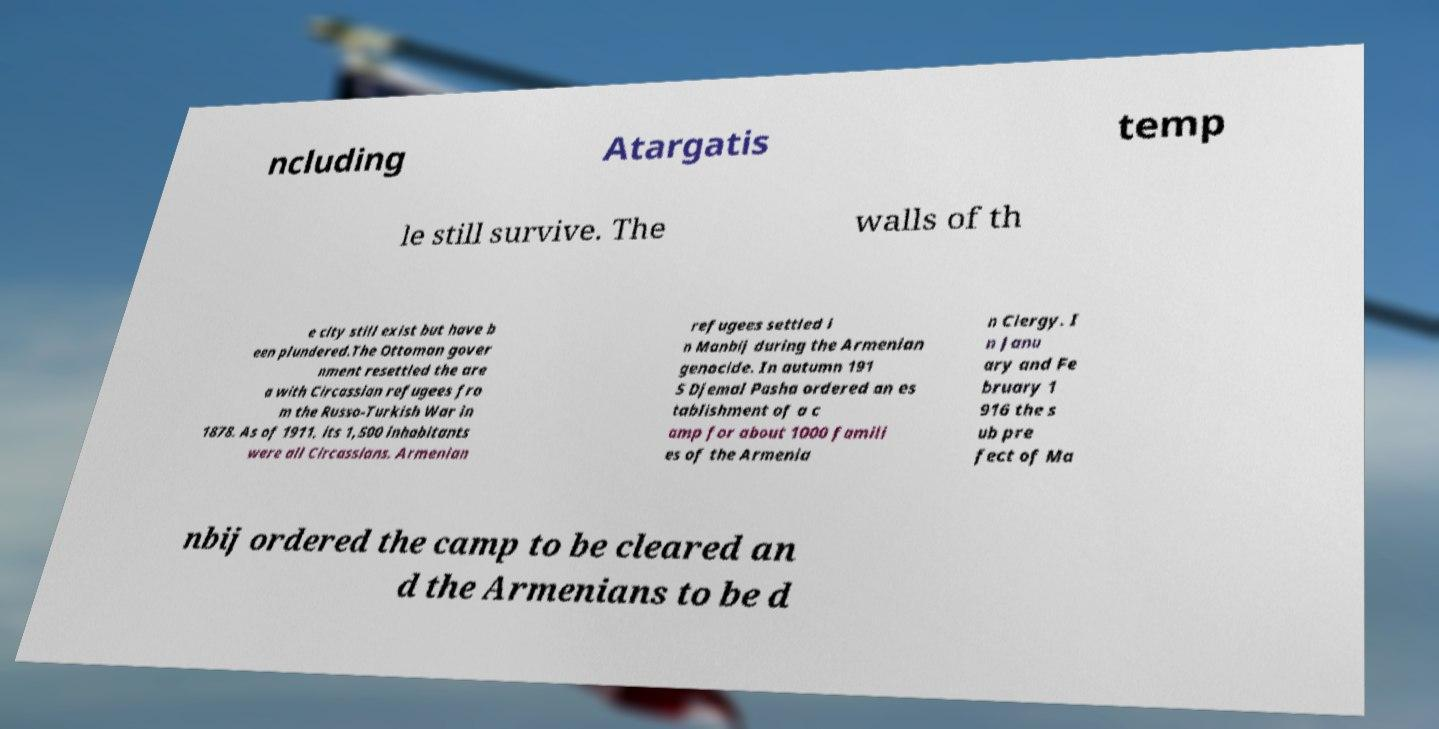Could you extract and type out the text from this image? ncluding Atargatis temp le still survive. The walls of th e city still exist but have b een plundered.The Ottoman gover nment resettled the are a with Circassian refugees fro m the Russo-Turkish War in 1878. As of 1911, its 1,500 inhabitants were all Circassians. Armenian refugees settled i n Manbij during the Armenian genocide. In autumn 191 5 Djemal Pasha ordered an es tablishment of a c amp for about 1000 famili es of the Armenia n Clergy. I n Janu ary and Fe bruary 1 916 the s ub pre fect of Ma nbij ordered the camp to be cleared an d the Armenians to be d 